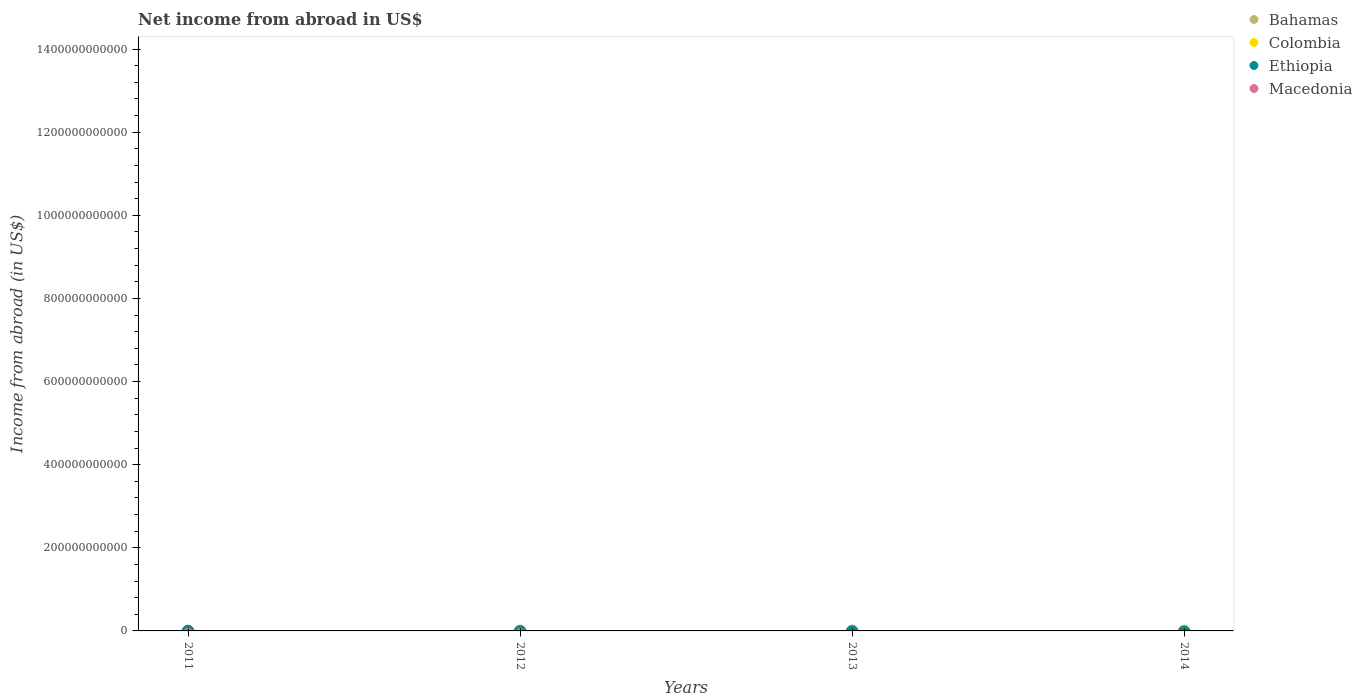Is the number of dotlines equal to the number of legend labels?
Ensure brevity in your answer.  No. What is the net income from abroad in Macedonia in 2012?
Your response must be concise. 0. Across all years, what is the minimum net income from abroad in Bahamas?
Ensure brevity in your answer.  0. What is the average net income from abroad in Bahamas per year?
Keep it short and to the point. 0. In how many years, is the net income from abroad in Colombia greater than 480000000000 US$?
Provide a short and direct response. 0. Is it the case that in every year, the sum of the net income from abroad in Colombia and net income from abroad in Bahamas  is greater than the net income from abroad in Macedonia?
Provide a succinct answer. No. Does the net income from abroad in Ethiopia monotonically increase over the years?
Provide a succinct answer. No. Is the net income from abroad in Macedonia strictly greater than the net income from abroad in Ethiopia over the years?
Ensure brevity in your answer.  No. What is the difference between two consecutive major ticks on the Y-axis?
Make the answer very short. 2.00e+11. How many legend labels are there?
Your answer should be compact. 4. What is the title of the graph?
Keep it short and to the point. Net income from abroad in US$. What is the label or title of the Y-axis?
Provide a short and direct response. Income from abroad (in US$). What is the Income from abroad (in US$) of Colombia in 2011?
Provide a succinct answer. 0. What is the Income from abroad (in US$) of Bahamas in 2012?
Your response must be concise. 0. What is the Income from abroad (in US$) of Colombia in 2012?
Provide a short and direct response. 0. What is the Income from abroad (in US$) in Ethiopia in 2012?
Offer a terse response. 0. What is the Income from abroad (in US$) of Macedonia in 2013?
Keep it short and to the point. 0. What is the Income from abroad (in US$) of Bahamas in 2014?
Give a very brief answer. 0. What is the Income from abroad (in US$) in Ethiopia in 2014?
Your answer should be compact. 0. What is the Income from abroad (in US$) in Macedonia in 2014?
Offer a very short reply. 0. What is the total Income from abroad (in US$) in Bahamas in the graph?
Offer a very short reply. 0. What is the total Income from abroad (in US$) in Macedonia in the graph?
Offer a very short reply. 0. What is the average Income from abroad (in US$) of Ethiopia per year?
Your response must be concise. 0. 